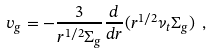Convert formula to latex. <formula><loc_0><loc_0><loc_500><loc_500>v _ { g } = - \frac { 3 } { r ^ { 1 / 2 } \Sigma _ { g } } \frac { d } { d r } ( r ^ { 1 / 2 } \nu _ { t } \Sigma _ { g } ) \ ,</formula> 